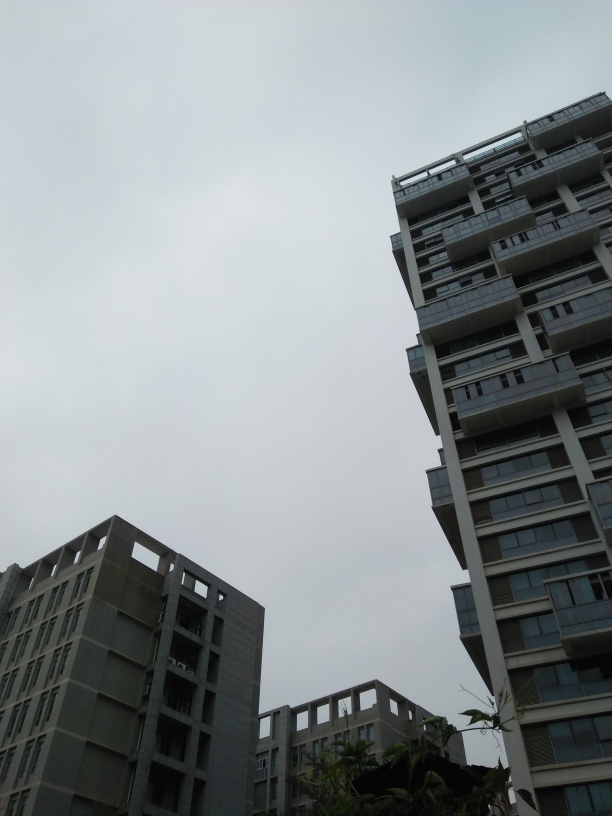Could you guess the possible location or country where this photo might have been taken? Without distinct cultural indicators, it's challenging to pinpoint a specific location. The architectural design is quite modern and could be indicative of urban residential areas in many parts of the world. The overcast climate might suggest a region with a temperate climate. 